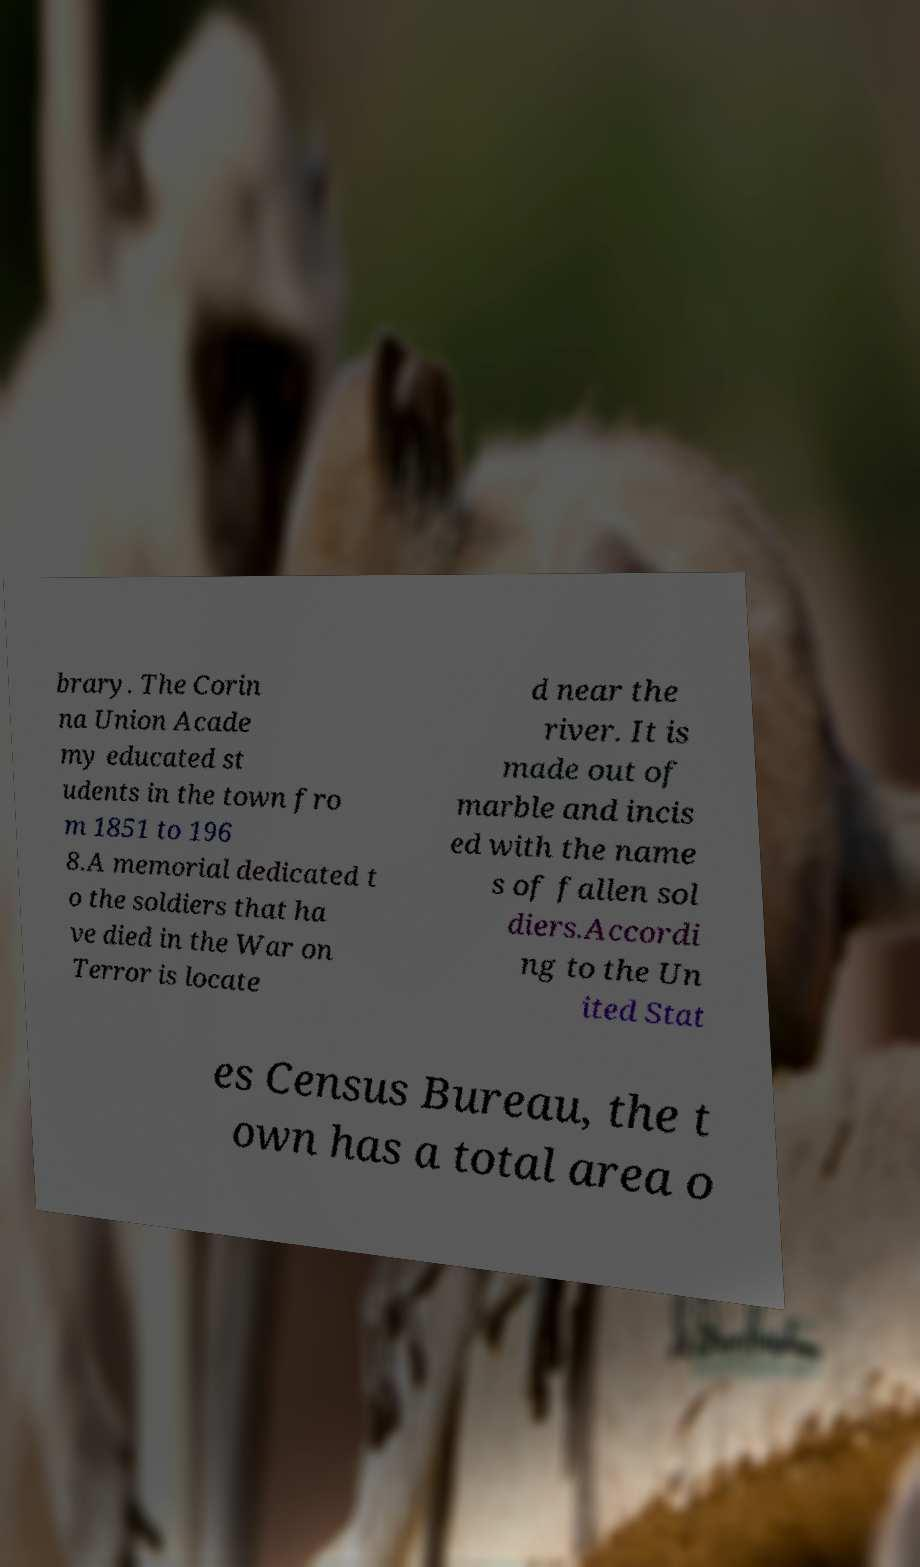Please read and relay the text visible in this image. What does it say? brary. The Corin na Union Acade my educated st udents in the town fro m 1851 to 196 8.A memorial dedicated t o the soldiers that ha ve died in the War on Terror is locate d near the river. It is made out of marble and incis ed with the name s of fallen sol diers.Accordi ng to the Un ited Stat es Census Bureau, the t own has a total area o 